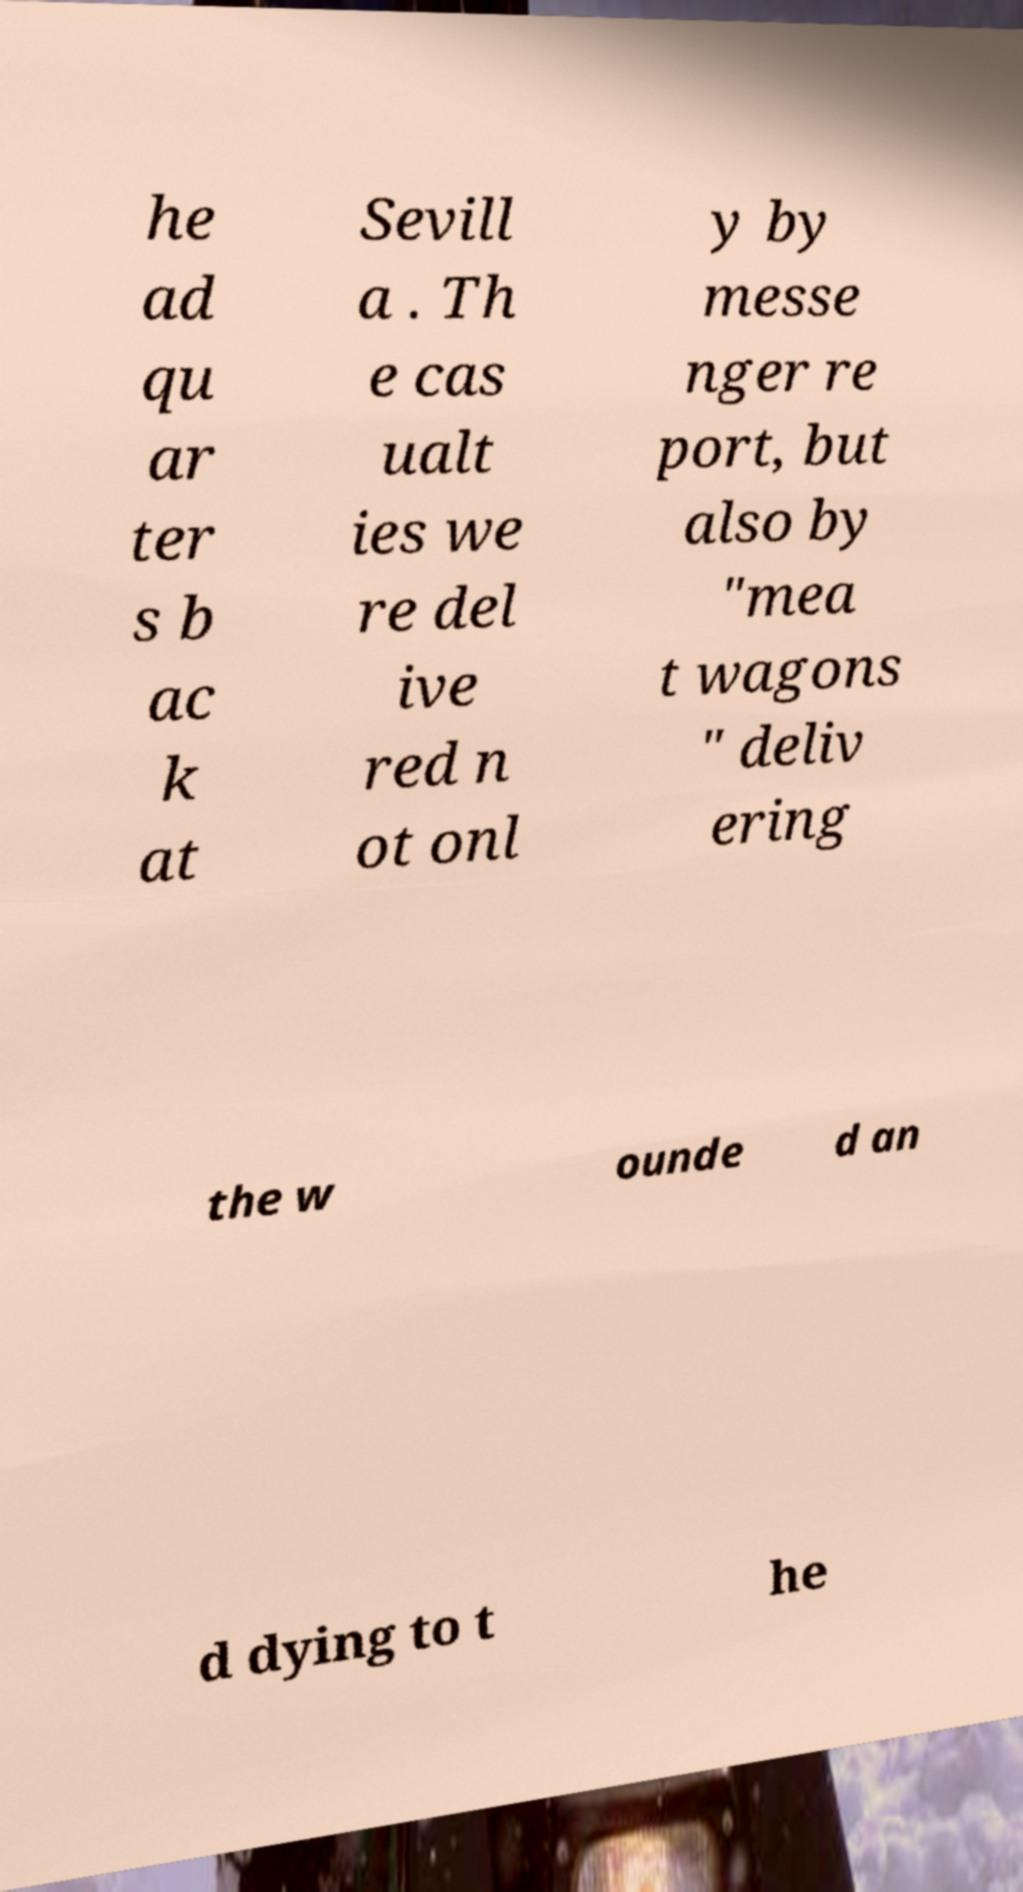For documentation purposes, I need the text within this image transcribed. Could you provide that? he ad qu ar ter s b ac k at Sevill a . Th e cas ualt ies we re del ive red n ot onl y by messe nger re port, but also by "mea t wagons " deliv ering the w ounde d an d dying to t he 